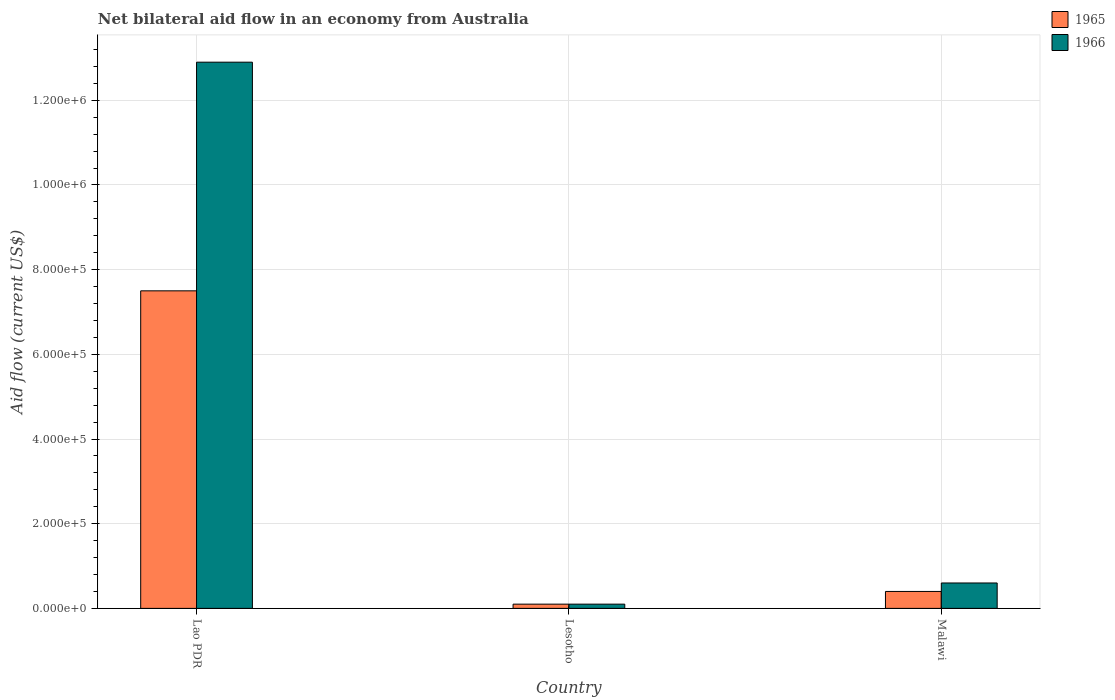How many groups of bars are there?
Your answer should be very brief. 3. Are the number of bars per tick equal to the number of legend labels?
Your answer should be compact. Yes. Are the number of bars on each tick of the X-axis equal?
Keep it short and to the point. Yes. What is the label of the 1st group of bars from the left?
Offer a very short reply. Lao PDR. In how many cases, is the number of bars for a given country not equal to the number of legend labels?
Your answer should be compact. 0. What is the net bilateral aid flow in 1965 in Lao PDR?
Provide a succinct answer. 7.50e+05. Across all countries, what is the maximum net bilateral aid flow in 1966?
Give a very brief answer. 1.29e+06. Across all countries, what is the minimum net bilateral aid flow in 1966?
Offer a very short reply. 10000. In which country was the net bilateral aid flow in 1965 maximum?
Make the answer very short. Lao PDR. In which country was the net bilateral aid flow in 1965 minimum?
Keep it short and to the point. Lesotho. What is the total net bilateral aid flow in 1966 in the graph?
Keep it short and to the point. 1.36e+06. What is the difference between the net bilateral aid flow in 1965 in Lao PDR and that in Malawi?
Your answer should be compact. 7.10e+05. What is the difference between the net bilateral aid flow in 1965 in Malawi and the net bilateral aid flow in 1966 in Lao PDR?
Offer a terse response. -1.25e+06. What is the average net bilateral aid flow in 1965 per country?
Your answer should be very brief. 2.67e+05. What is the difference between the net bilateral aid flow of/in 1966 and net bilateral aid flow of/in 1965 in Malawi?
Ensure brevity in your answer.  2.00e+04. Is the net bilateral aid flow in 1965 in Lesotho less than that in Malawi?
Ensure brevity in your answer.  Yes. Is the difference between the net bilateral aid flow in 1966 in Lao PDR and Lesotho greater than the difference between the net bilateral aid flow in 1965 in Lao PDR and Lesotho?
Provide a succinct answer. Yes. What is the difference between the highest and the second highest net bilateral aid flow in 1966?
Your response must be concise. 1.28e+06. What is the difference between the highest and the lowest net bilateral aid flow in 1965?
Your answer should be compact. 7.40e+05. Is the sum of the net bilateral aid flow in 1966 in Lesotho and Malawi greater than the maximum net bilateral aid flow in 1965 across all countries?
Offer a terse response. No. What does the 1st bar from the left in Malawi represents?
Provide a succinct answer. 1965. What does the 2nd bar from the right in Lesotho represents?
Provide a succinct answer. 1965. Are all the bars in the graph horizontal?
Ensure brevity in your answer.  No. Does the graph contain any zero values?
Keep it short and to the point. No. Does the graph contain grids?
Offer a terse response. Yes. Where does the legend appear in the graph?
Provide a succinct answer. Top right. How many legend labels are there?
Ensure brevity in your answer.  2. How are the legend labels stacked?
Make the answer very short. Vertical. What is the title of the graph?
Offer a terse response. Net bilateral aid flow in an economy from Australia. What is the label or title of the Y-axis?
Ensure brevity in your answer.  Aid flow (current US$). What is the Aid flow (current US$) in 1965 in Lao PDR?
Keep it short and to the point. 7.50e+05. What is the Aid flow (current US$) of 1966 in Lao PDR?
Provide a succinct answer. 1.29e+06. What is the Aid flow (current US$) in 1965 in Lesotho?
Your answer should be compact. 10000. What is the Aid flow (current US$) of 1966 in Lesotho?
Ensure brevity in your answer.  10000. What is the Aid flow (current US$) of 1965 in Malawi?
Your answer should be compact. 4.00e+04. What is the Aid flow (current US$) in 1966 in Malawi?
Your answer should be compact. 6.00e+04. Across all countries, what is the maximum Aid flow (current US$) of 1965?
Offer a very short reply. 7.50e+05. Across all countries, what is the maximum Aid flow (current US$) of 1966?
Provide a succinct answer. 1.29e+06. Across all countries, what is the minimum Aid flow (current US$) of 1965?
Keep it short and to the point. 10000. What is the total Aid flow (current US$) in 1966 in the graph?
Your answer should be very brief. 1.36e+06. What is the difference between the Aid flow (current US$) of 1965 in Lao PDR and that in Lesotho?
Your response must be concise. 7.40e+05. What is the difference between the Aid flow (current US$) of 1966 in Lao PDR and that in Lesotho?
Give a very brief answer. 1.28e+06. What is the difference between the Aid flow (current US$) in 1965 in Lao PDR and that in Malawi?
Ensure brevity in your answer.  7.10e+05. What is the difference between the Aid flow (current US$) of 1966 in Lao PDR and that in Malawi?
Provide a short and direct response. 1.23e+06. What is the difference between the Aid flow (current US$) of 1965 in Lao PDR and the Aid flow (current US$) of 1966 in Lesotho?
Make the answer very short. 7.40e+05. What is the difference between the Aid flow (current US$) of 1965 in Lao PDR and the Aid flow (current US$) of 1966 in Malawi?
Keep it short and to the point. 6.90e+05. What is the difference between the Aid flow (current US$) of 1965 in Lesotho and the Aid flow (current US$) of 1966 in Malawi?
Keep it short and to the point. -5.00e+04. What is the average Aid flow (current US$) in 1965 per country?
Make the answer very short. 2.67e+05. What is the average Aid flow (current US$) in 1966 per country?
Give a very brief answer. 4.53e+05. What is the difference between the Aid flow (current US$) of 1965 and Aid flow (current US$) of 1966 in Lao PDR?
Keep it short and to the point. -5.40e+05. What is the ratio of the Aid flow (current US$) in 1965 in Lao PDR to that in Lesotho?
Your response must be concise. 75. What is the ratio of the Aid flow (current US$) of 1966 in Lao PDR to that in Lesotho?
Offer a very short reply. 129. What is the ratio of the Aid flow (current US$) in 1965 in Lao PDR to that in Malawi?
Give a very brief answer. 18.75. What is the ratio of the Aid flow (current US$) in 1966 in Lao PDR to that in Malawi?
Offer a very short reply. 21.5. What is the ratio of the Aid flow (current US$) in 1965 in Lesotho to that in Malawi?
Keep it short and to the point. 0.25. What is the ratio of the Aid flow (current US$) in 1966 in Lesotho to that in Malawi?
Keep it short and to the point. 0.17. What is the difference between the highest and the second highest Aid flow (current US$) in 1965?
Provide a short and direct response. 7.10e+05. What is the difference between the highest and the second highest Aid flow (current US$) of 1966?
Your answer should be very brief. 1.23e+06. What is the difference between the highest and the lowest Aid flow (current US$) in 1965?
Your response must be concise. 7.40e+05. What is the difference between the highest and the lowest Aid flow (current US$) of 1966?
Provide a short and direct response. 1.28e+06. 